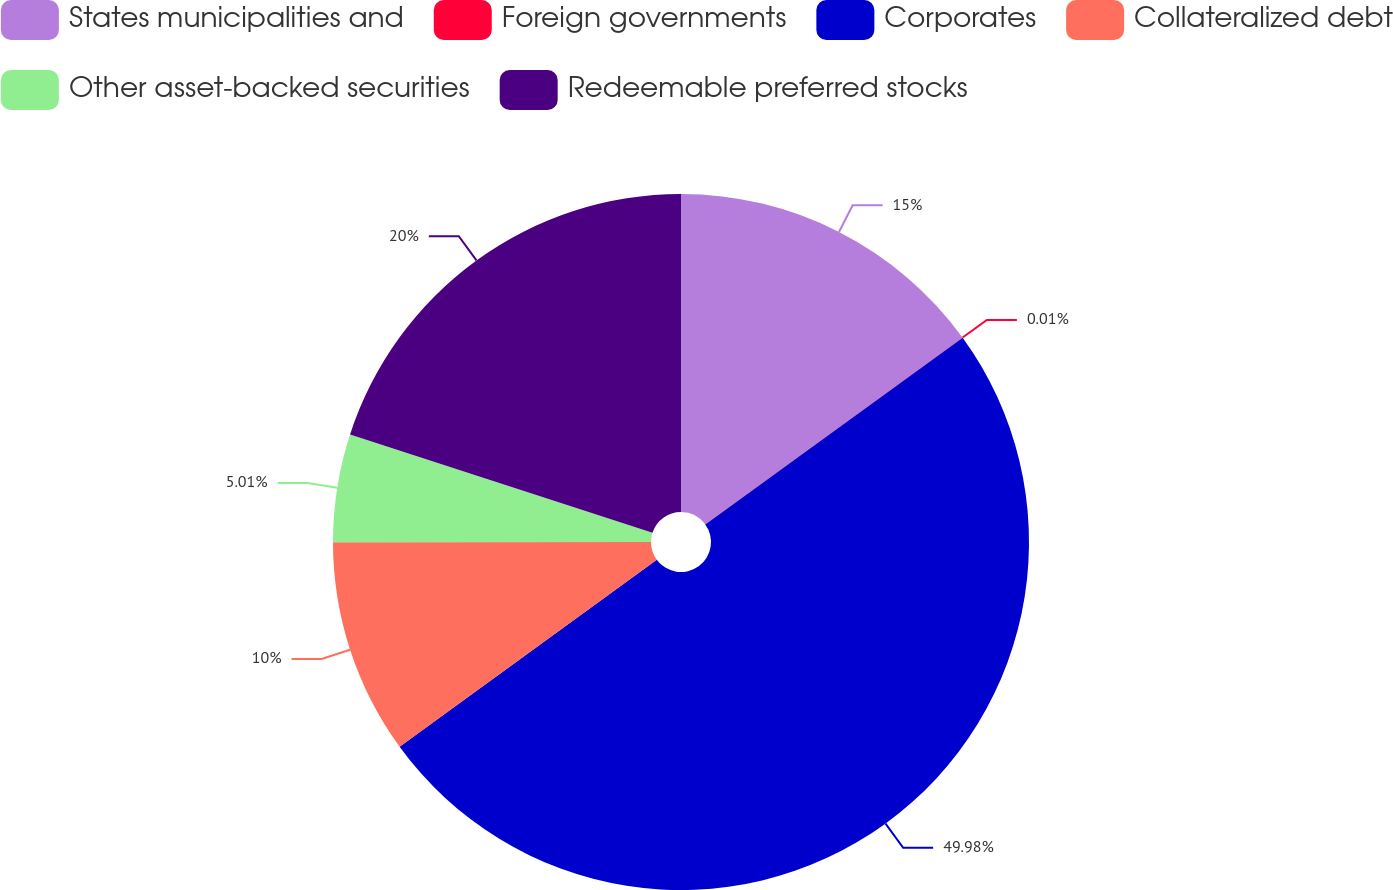<chart> <loc_0><loc_0><loc_500><loc_500><pie_chart><fcel>States municipalities and<fcel>Foreign governments<fcel>Corporates<fcel>Collateralized debt<fcel>Other asset-backed securities<fcel>Redeemable preferred stocks<nl><fcel>15.0%<fcel>0.01%<fcel>49.98%<fcel>10.0%<fcel>5.01%<fcel>20.0%<nl></chart> 